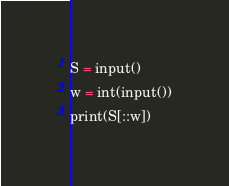Convert code to text. <code><loc_0><loc_0><loc_500><loc_500><_Python_>S = input()
w = int(input())
print(S[::w])
</code> 